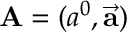Convert formula to latex. <formula><loc_0><loc_0><loc_500><loc_500>A = ( a ^ { 0 } , { \vec { a } } )</formula> 